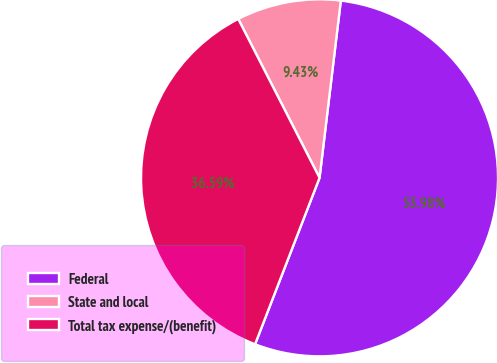Convert chart. <chart><loc_0><loc_0><loc_500><loc_500><pie_chart><fcel>Federal<fcel>State and local<fcel>Total tax expense/(benefit)<nl><fcel>53.98%<fcel>9.43%<fcel>36.59%<nl></chart> 